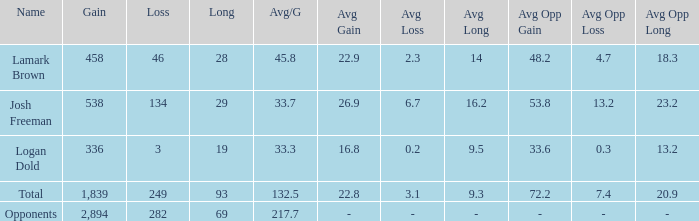Can you parse all the data within this table? {'header': ['Name', 'Gain', 'Loss', 'Long', 'Avg/G', 'Avg Gain', 'Avg Loss', 'Avg Long', 'Avg Opp Gain', 'Avg Opp Loss', 'Avg Opp Long'], 'rows': [['Lamark Brown', '458', '46', '28', '45.8', '22.9', '2.3', '14', '48.2', '4.7', '18.3'], ['Josh Freeman', '538', '134', '29', '33.7', '26.9', '6.7', '16.2', '53.8', '13.2', '23.2'], ['Logan Dold', '336', '3', '19', '33.3', '16.8', '0.2', '9.5', '33.6', '0.3', '13.2'], ['Total', '1,839', '249', '93', '132.5', '22.8', '3.1', '9.3', '72.2', '7.4', '20.9'], ['Opponents', '2,894', '282', '69', '217.7', '-', '-', '-', '-', '-', '-']]} What is the gain for a long of 29 with an avg/g less than 33.7? 0.0. 